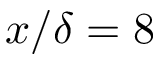Convert formula to latex. <formula><loc_0><loc_0><loc_500><loc_500>x / \delta = 8</formula> 